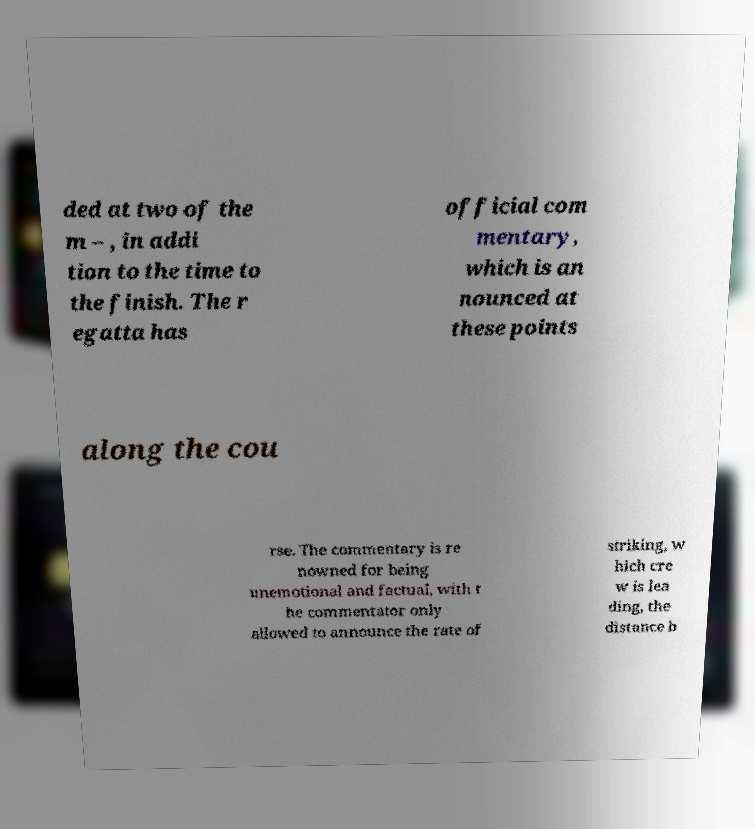What messages or text are displayed in this image? I need them in a readable, typed format. ded at two of the m – , in addi tion to the time to the finish. The r egatta has official com mentary, which is an nounced at these points along the cou rse. The commentary is re nowned for being unemotional and factual, with t he commentator only allowed to announce the rate of striking, w hich cre w is lea ding, the distance b 